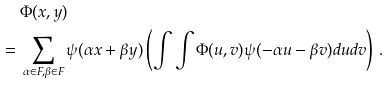<formula> <loc_0><loc_0><loc_500><loc_500>& \ \Phi ( x , y ) \\ = & \ \sum _ { \alpha \in F , \beta \in F } \psi ( \alpha x + \beta y ) \left ( \int \int \Phi ( u , v ) \psi ( - \alpha u - \beta v ) d u d v \right ) \, .</formula> 